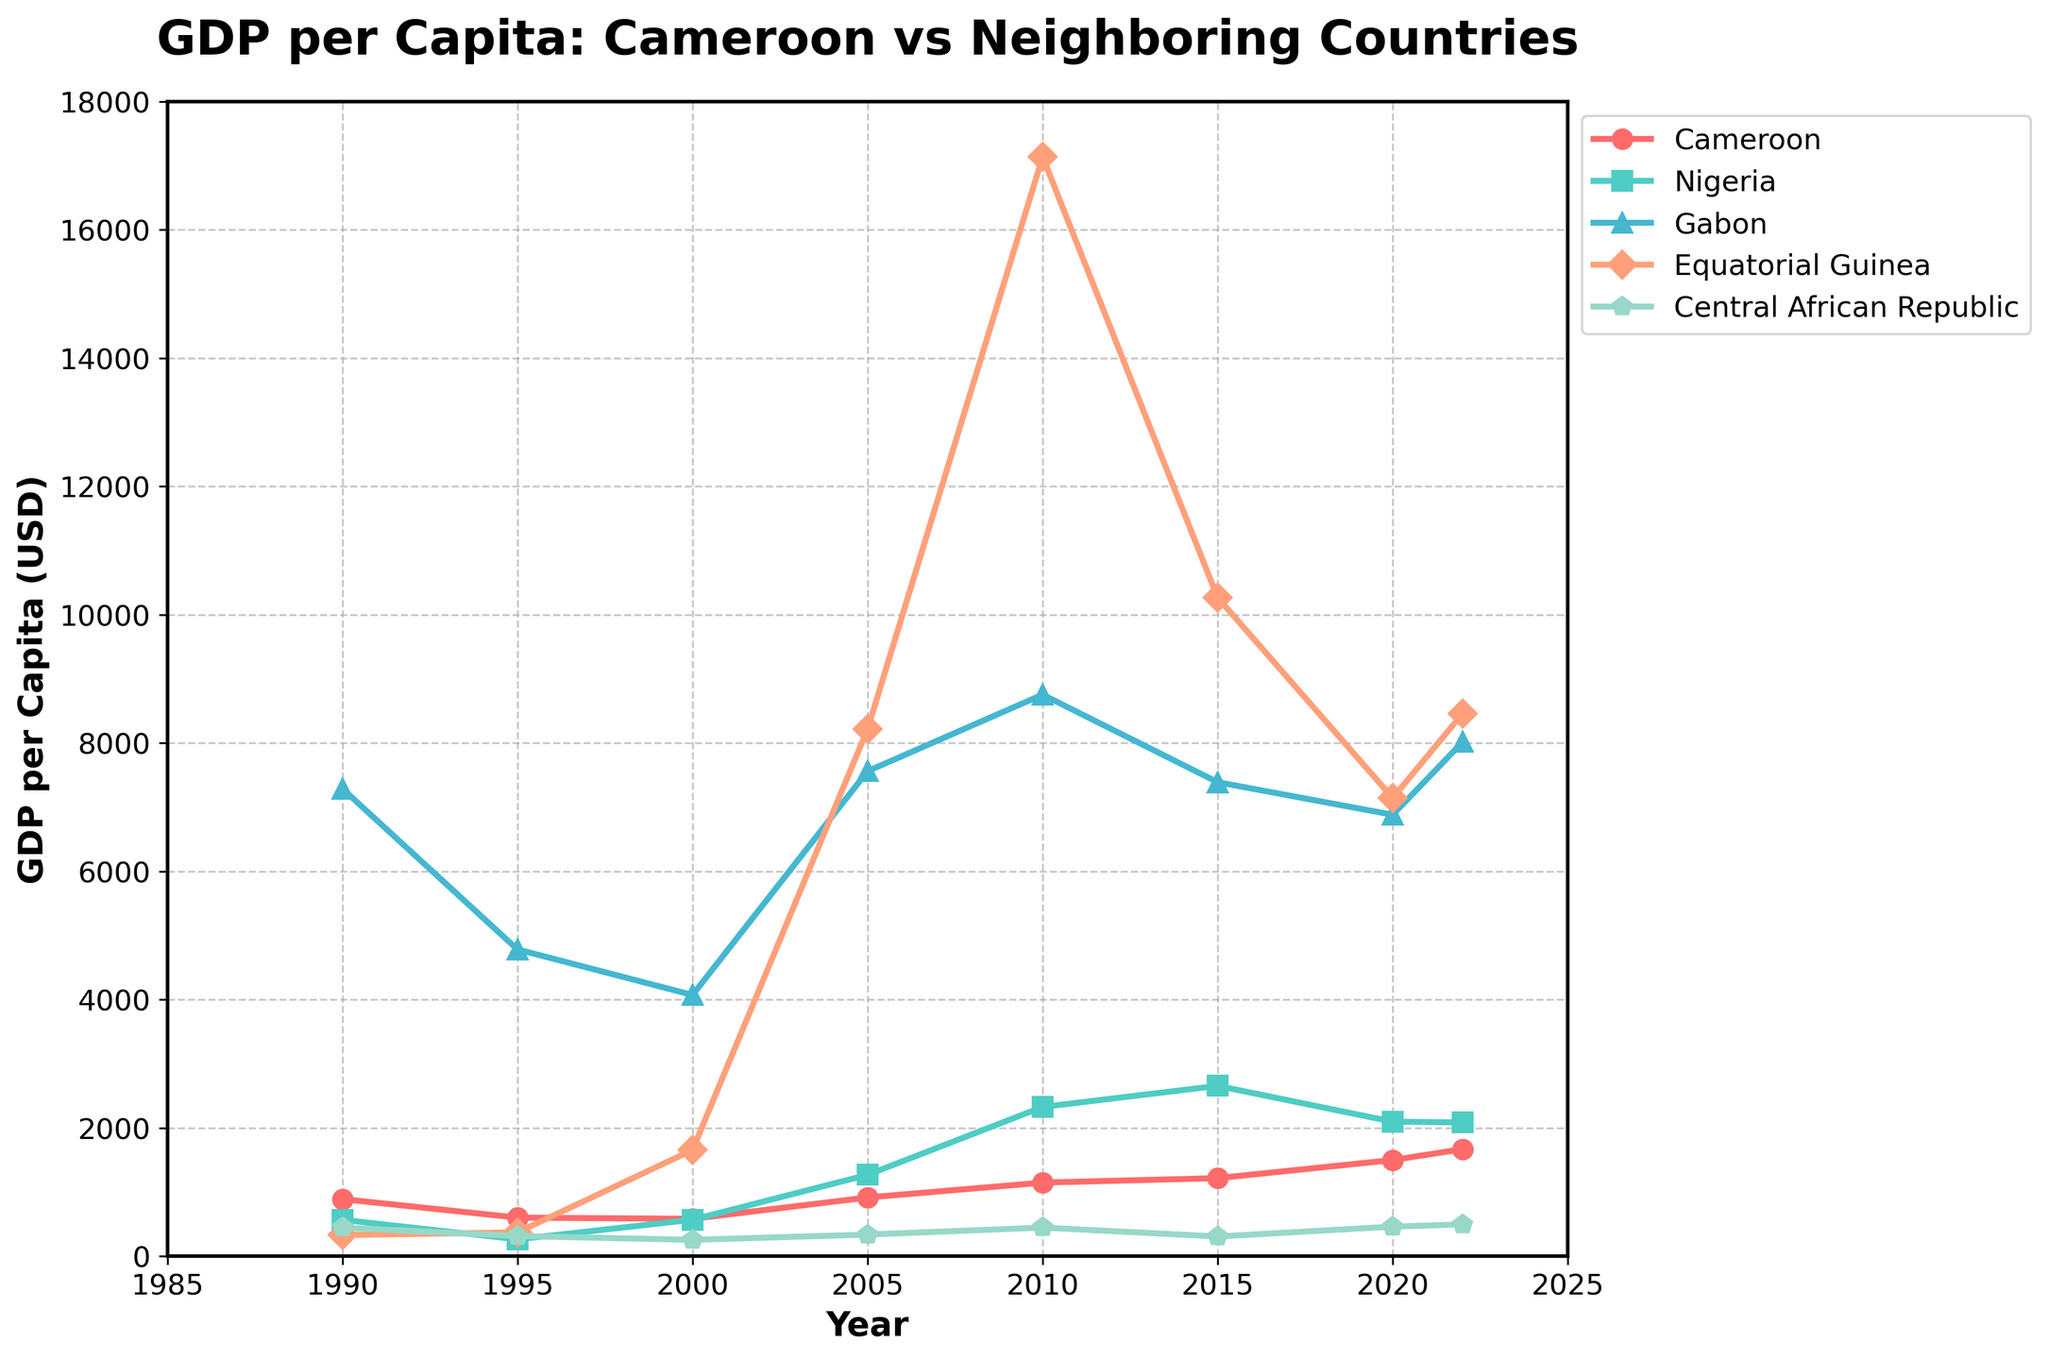Which country had the highest GDP per capita in 2022? By looking at the data for the year 2022, Equatorial Guinea has the highest GDP per capita at 8462 USD.
Answer: Equatorial Guinea Which country had the lowest GDP per capita in 2000 and what was the value? According to the data for the year 2000, the Central African Republic had the lowest GDP per capita at 255 USD.
Answer: Central African Republic, 255 USD How did Cameroon's GDP per capita change from 1990 to 2000? In 1990, Cameroon's GDP per capita was 890 USD, and by 2000, it dropped to 583 USD. Calculating the difference: 583 - 890 = -307. This shows a decrease of 307 USD over this period.
Answer: Decreased by 307 USD Which neighboring country had the largest increase in GDP per capita between 2000 and 2010? Comparing the GDP per capita in 2000 and 2010, Equatorial Guinea increased from 1655 USD to 17136 USD. The increase is 17136 - 1655 = 15481 USD, which is the largest among the countries.
Answer: Equatorial Guinea How does the peak GDP per capita of Gabon compare to the peak of Nigeria in the given timeframe? Gabon's peak value is in 2010 at 8754 USD, and Nigeria's peak value is in the same year at 2327 USD. Comparing these two values: 8754 (Gabon) is greater than 2327 (Nigeria).
Answer: Gabon > Nigeria What is the overall trend of GDP per capita for Cameroon from 1990 to 2022? The GDP per capita for Cameroon started at 890 USD in 1990 and increased to 1669 USD by 2022, showing an overall increasing trend.
Answer: Increasing trend Which country shows the biggest fluctuation in GDP per capita over the given years? To identify the biggest fluctuation, we should look at the highest and lowest values over the years. Equatorial Guinea's GDP per capita ranged from 330 USD in 1990 to 17136 USD in 2010, indicating the most significant fluctuation of 16806 USD.
Answer: Equatorial Guinea What is the average GDP per capita for the Central African Republic over the given years? Summing up the values for the Central African Republic over the years (446 + 314 + 255 + 337 + 446 + 307 + 461 + 496 = 3062) and dividing by the number of years (8), we get 3062 / 8 = 382.75 USD.
Answer: 382.75 USD Is there any year where Cameroon's GDP per capita surpassed Nigeria's? By comparing Cameroon's and Nigeria's GDP per capita each year, we observe that in 1990 (890 vs 567 USD) and 1995 (601 vs 263 USD), Cameroon's GDP per capita was higher than that of Nigeria.
Answer: 1990, 1995 What’s the difference between the maximum GDP per capita of Gabon and Equatorial Guinea within the given period? Gabon's peak GDP per capita is 8754 USD in 2010. Equatorial Guinea's peak is 17136 USD in 2010. The difference is 17136 - 8754 = 8382 USD.
Answer: 8382 USD 